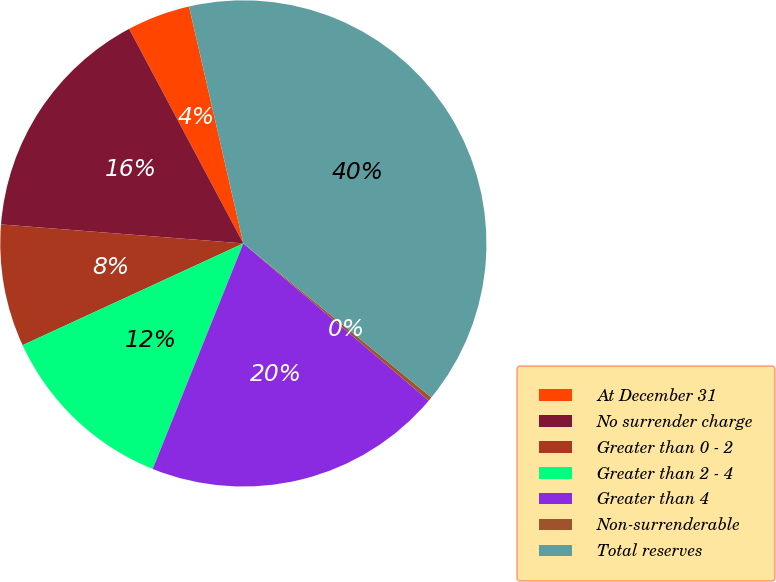<chart> <loc_0><loc_0><loc_500><loc_500><pie_chart><fcel>At December 31<fcel>No surrender charge<fcel>Greater than 0 - 2<fcel>Greater than 2 - 4<fcel>Greater than 4<fcel>Non-surrenderable<fcel>Total reserves<nl><fcel>4.2%<fcel>15.97%<fcel>8.12%<fcel>12.04%<fcel>19.89%<fcel>0.27%<fcel>39.51%<nl></chart> 